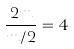Convert formula to latex. <formula><loc_0><loc_0><loc_500><loc_500>\frac { 2 m } { m / 2 } = 4</formula> 